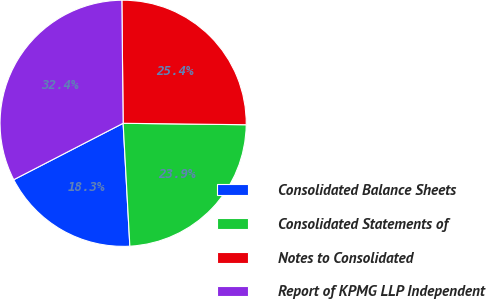Convert chart. <chart><loc_0><loc_0><loc_500><loc_500><pie_chart><fcel>Consolidated Balance Sheets<fcel>Consolidated Statements of<fcel>Notes to Consolidated<fcel>Report of KPMG LLP Independent<nl><fcel>18.29%<fcel>23.94%<fcel>25.35%<fcel>32.41%<nl></chart> 